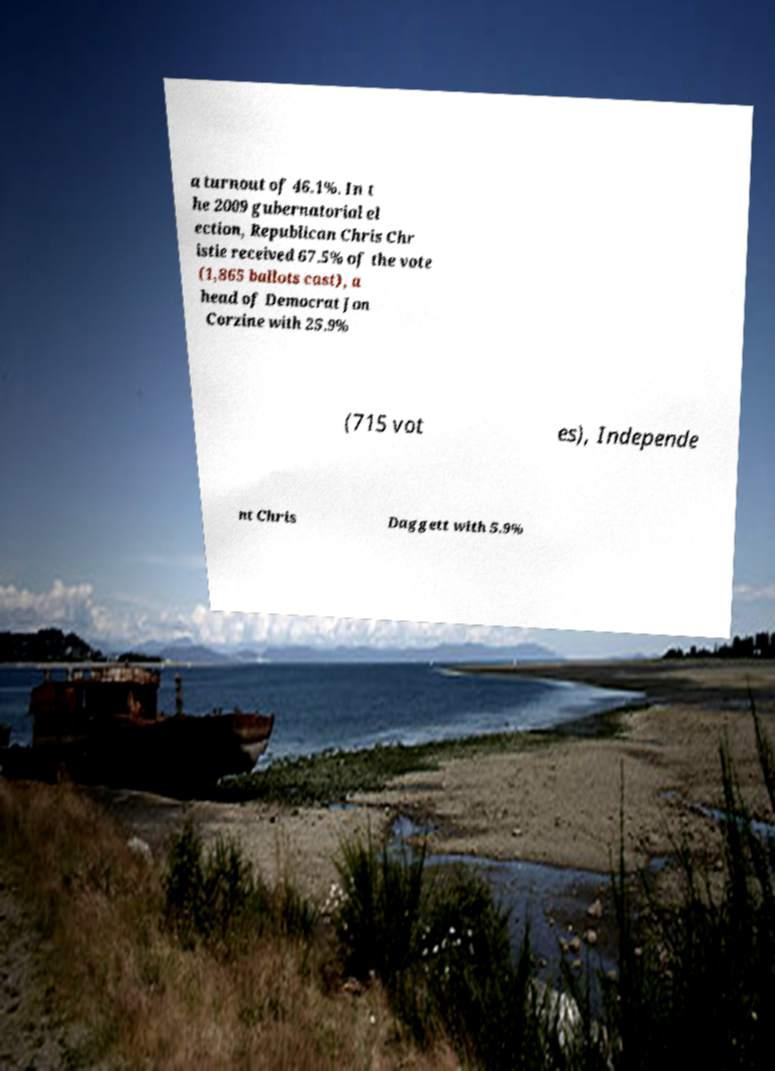Can you accurately transcribe the text from the provided image for me? a turnout of 46.1%. In t he 2009 gubernatorial el ection, Republican Chris Chr istie received 67.5% of the vote (1,865 ballots cast), a head of Democrat Jon Corzine with 25.9% (715 vot es), Independe nt Chris Daggett with 5.9% 